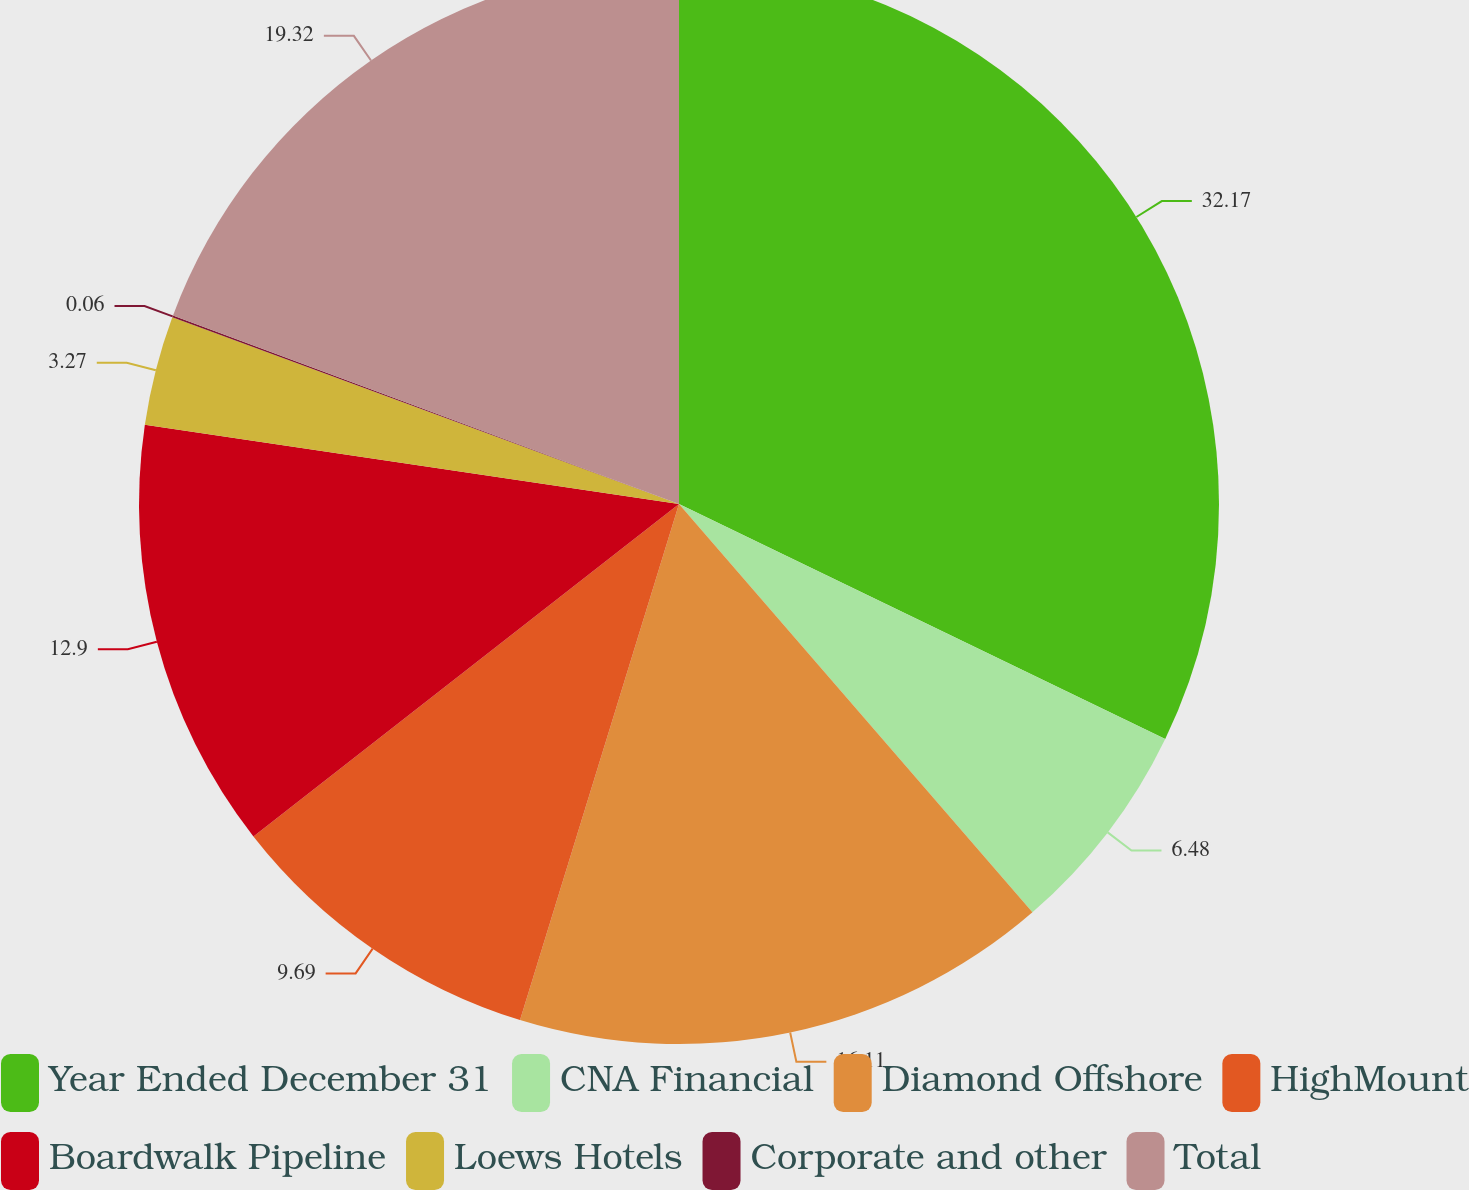Convert chart to OTSL. <chart><loc_0><loc_0><loc_500><loc_500><pie_chart><fcel>Year Ended December 31<fcel>CNA Financial<fcel>Diamond Offshore<fcel>HighMount<fcel>Boardwalk Pipeline<fcel>Loews Hotels<fcel>Corporate and other<fcel>Total<nl><fcel>32.16%<fcel>6.48%<fcel>16.11%<fcel>9.69%<fcel>12.9%<fcel>3.27%<fcel>0.06%<fcel>19.32%<nl></chart> 